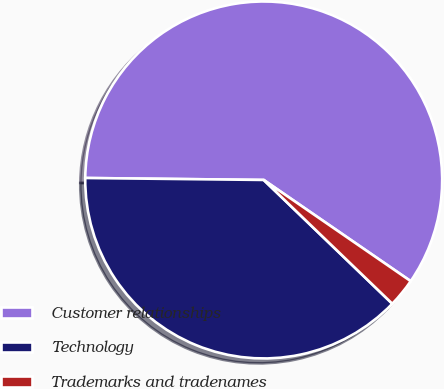Convert chart to OTSL. <chart><loc_0><loc_0><loc_500><loc_500><pie_chart><fcel>Customer relationships<fcel>Technology<fcel>Trademarks and tradenames<nl><fcel>59.42%<fcel>37.98%<fcel>2.6%<nl></chart> 